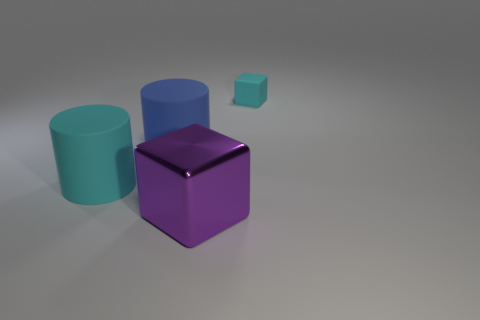Is there any other thing that is the same size as the cyan block?
Make the answer very short. No. Is there any other thing that has the same material as the cyan cylinder?
Your response must be concise. Yes. There is a large rubber object left of the big blue matte object; is its shape the same as the rubber object to the right of the big shiny block?
Provide a succinct answer. No. Are there fewer cyan cubes that are in front of the cyan matte cylinder than large blue rubber objects?
Your answer should be compact. Yes. What number of other things are the same color as the large metallic object?
Ensure brevity in your answer.  0. There is a cyan matte object that is left of the small rubber object; how big is it?
Ensure brevity in your answer.  Large. There is a cyan rubber object to the right of the cube in front of the cyan object on the left side of the big metal object; what is its shape?
Provide a succinct answer. Cube. What shape is the big thing that is left of the purple block and right of the cyan cylinder?
Offer a terse response. Cylinder. Is there a blue metallic block that has the same size as the matte cube?
Your answer should be very brief. No. Is the shape of the cyan matte thing that is behind the large cyan object the same as  the blue matte thing?
Give a very brief answer. No. 